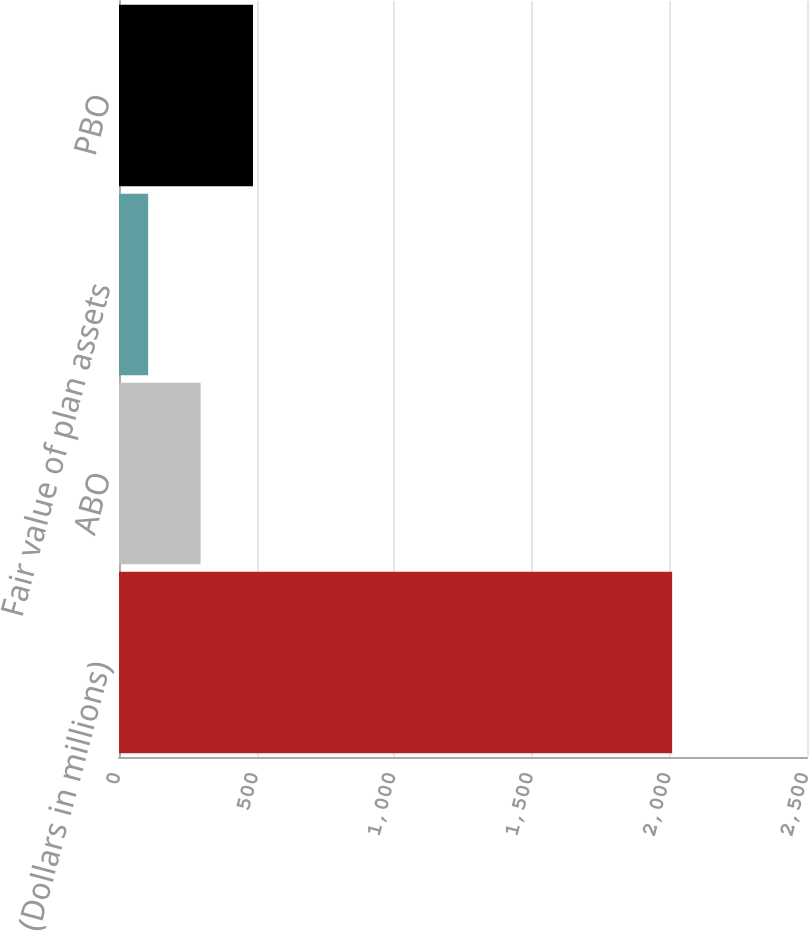Convert chart to OTSL. <chart><loc_0><loc_0><loc_500><loc_500><bar_chart><fcel>(Dollars in millions)<fcel>ABO<fcel>Fair value of plan assets<fcel>PBO<nl><fcel>2010<fcel>296.4<fcel>106<fcel>486.8<nl></chart> 